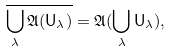Convert formula to latex. <formula><loc_0><loc_0><loc_500><loc_500>\overline { \bigcup _ { \lambda } \mathfrak A ( \mathsf U _ { \lambda } ) } = \mathfrak A ( \bigcup _ { \lambda } \mathsf U _ { \lambda } ) ,</formula> 